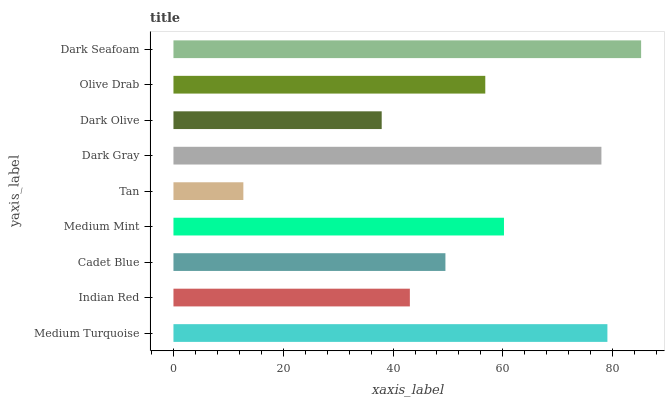Is Tan the minimum?
Answer yes or no. Yes. Is Dark Seafoam the maximum?
Answer yes or no. Yes. Is Indian Red the minimum?
Answer yes or no. No. Is Indian Red the maximum?
Answer yes or no. No. Is Medium Turquoise greater than Indian Red?
Answer yes or no. Yes. Is Indian Red less than Medium Turquoise?
Answer yes or no. Yes. Is Indian Red greater than Medium Turquoise?
Answer yes or no. No. Is Medium Turquoise less than Indian Red?
Answer yes or no. No. Is Olive Drab the high median?
Answer yes or no. Yes. Is Olive Drab the low median?
Answer yes or no. Yes. Is Indian Red the high median?
Answer yes or no. No. Is Tan the low median?
Answer yes or no. No. 